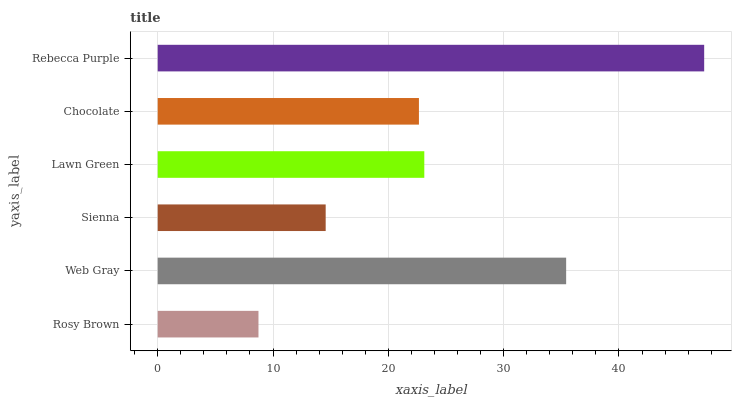Is Rosy Brown the minimum?
Answer yes or no. Yes. Is Rebecca Purple the maximum?
Answer yes or no. Yes. Is Web Gray the minimum?
Answer yes or no. No. Is Web Gray the maximum?
Answer yes or no. No. Is Web Gray greater than Rosy Brown?
Answer yes or no. Yes. Is Rosy Brown less than Web Gray?
Answer yes or no. Yes. Is Rosy Brown greater than Web Gray?
Answer yes or no. No. Is Web Gray less than Rosy Brown?
Answer yes or no. No. Is Lawn Green the high median?
Answer yes or no. Yes. Is Chocolate the low median?
Answer yes or no. Yes. Is Chocolate the high median?
Answer yes or no. No. Is Rebecca Purple the low median?
Answer yes or no. No. 